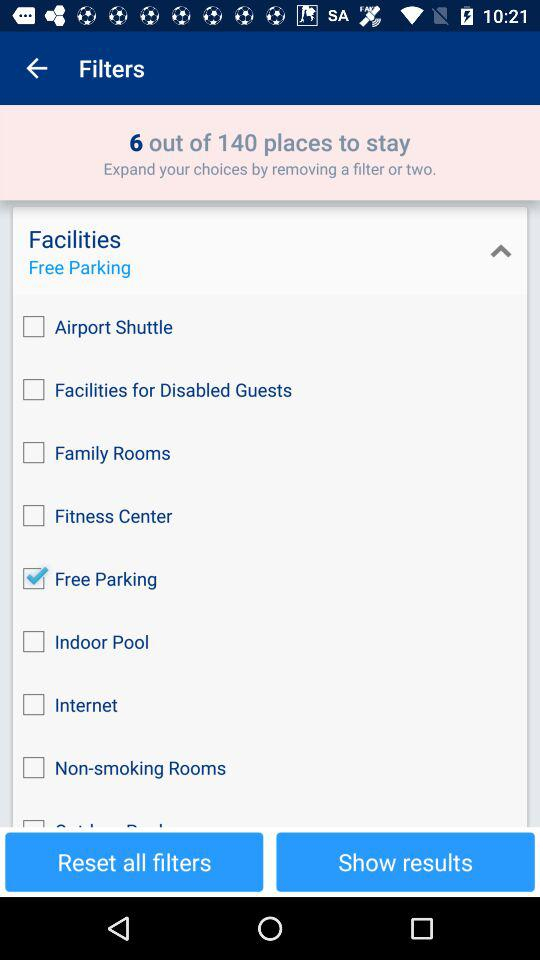Which option is selected in "Facilities"? The selected option is "Free Parking". 